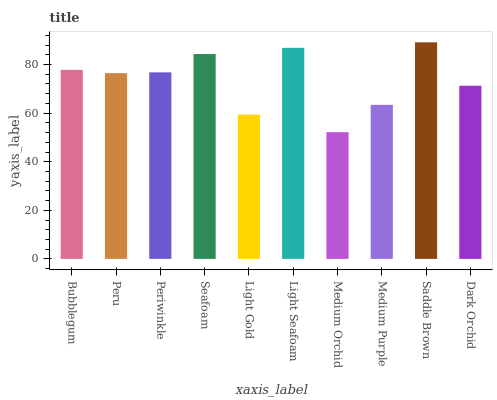Is Medium Orchid the minimum?
Answer yes or no. Yes. Is Saddle Brown the maximum?
Answer yes or no. Yes. Is Peru the minimum?
Answer yes or no. No. Is Peru the maximum?
Answer yes or no. No. Is Bubblegum greater than Peru?
Answer yes or no. Yes. Is Peru less than Bubblegum?
Answer yes or no. Yes. Is Peru greater than Bubblegum?
Answer yes or no. No. Is Bubblegum less than Peru?
Answer yes or no. No. Is Periwinkle the high median?
Answer yes or no. Yes. Is Peru the low median?
Answer yes or no. Yes. Is Light Seafoam the high median?
Answer yes or no. No. Is Periwinkle the low median?
Answer yes or no. No. 